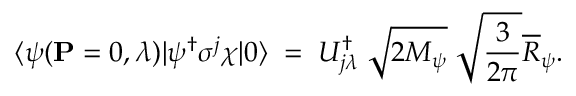<formula> <loc_0><loc_0><loc_500><loc_500>\langle \psi ( { P } = 0 , \lambda ) | \psi ^ { \dagger } \sigma ^ { j } \chi | 0 \rangle \, = \, U _ { j \lambda } ^ { \dagger } \, \sqrt { 2 M _ { \psi } } \, \sqrt { \frac { 3 } { 2 \pi } } \overline { R } _ { \psi } .</formula> 